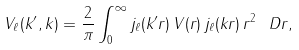<formula> <loc_0><loc_0><loc_500><loc_500>V _ { \ell } ( k ^ { \prime } , k ) = \frac { 2 } { \pi } \int _ { 0 } ^ { \infty } j _ { \ell } ( k ^ { \prime } r ) \, V ( r ) \, j _ { \ell } ( k r ) \, r ^ { 2 } \, \ D r ,</formula> 